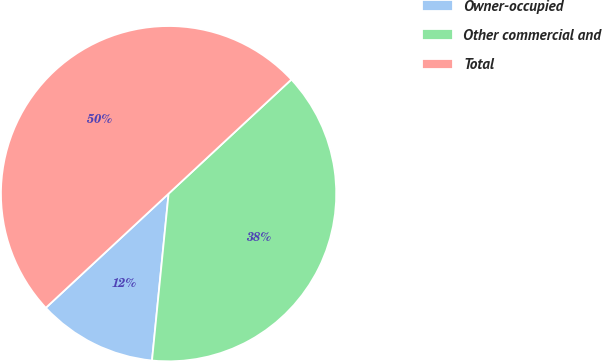Convert chart to OTSL. <chart><loc_0><loc_0><loc_500><loc_500><pie_chart><fcel>Owner-occupied<fcel>Other commercial and<fcel>Total<nl><fcel>11.5%<fcel>38.5%<fcel>50.0%<nl></chart> 